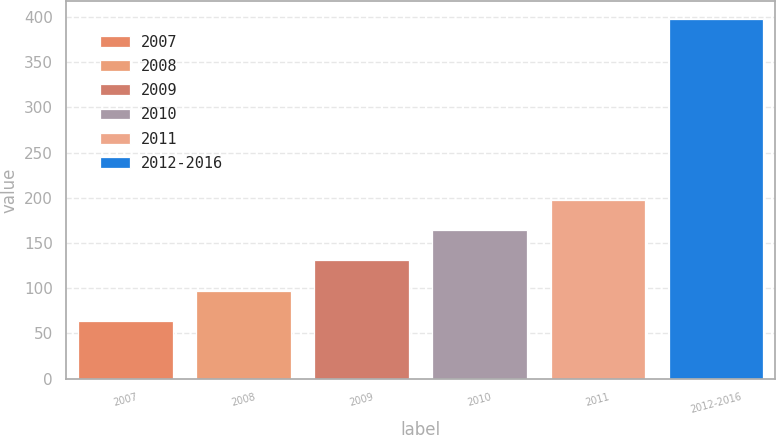Convert chart to OTSL. <chart><loc_0><loc_0><loc_500><loc_500><bar_chart><fcel>2007<fcel>2008<fcel>2009<fcel>2010<fcel>2011<fcel>2012-2016<nl><fcel>64<fcel>97.35<fcel>130.7<fcel>164.05<fcel>197.4<fcel>397.5<nl></chart> 